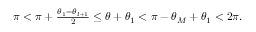<formula> <loc_0><loc_0><loc_500><loc_500>\begin{array} { r } { \pi < \pi + \frac { \theta _ { 1 } - \theta _ { l + 1 } } { 2 } \leq \theta + \theta _ { 1 } < \pi - \theta _ { M } + \theta _ { 1 } < 2 \pi . } \end{array}</formula> 